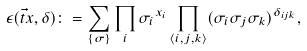<formula> <loc_0><loc_0><loc_500><loc_500>\epsilon ( \vec { t } x , \delta ) \colon = \sum _ { \{ \sigma \} } \prod _ { i } { \sigma _ { i } } ^ { x _ { i } } \prod _ { \langle i , j , k \rangle } ( \sigma _ { i } \sigma _ { j } \sigma _ { k } ) ^ { \delta _ { i j k } } ,</formula> 